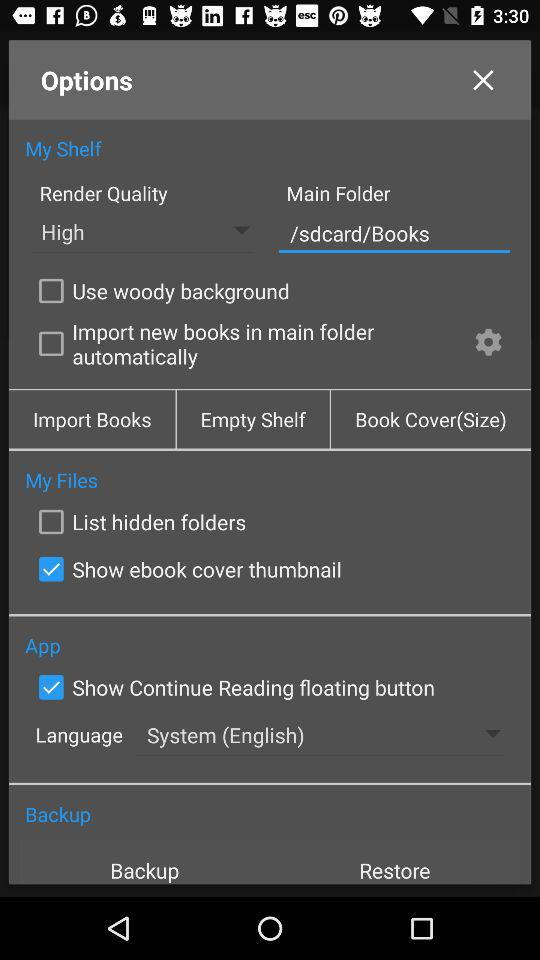What is the language? The language is English. 